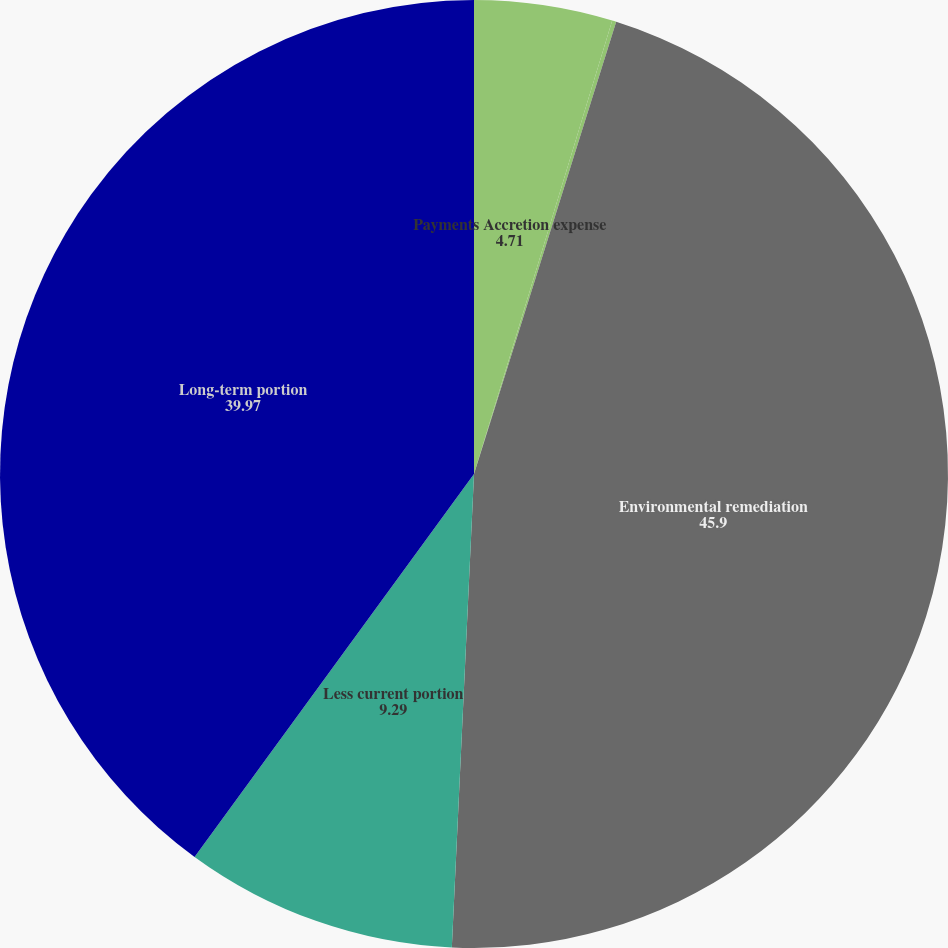<chart> <loc_0><loc_0><loc_500><loc_500><pie_chart><fcel>Payments Accretion expense<fcel>Acquisitions net of<fcel>Environmental remediation<fcel>Less current portion<fcel>Long-term portion<nl><fcel>4.71%<fcel>0.14%<fcel>45.9%<fcel>9.29%<fcel>39.97%<nl></chart> 